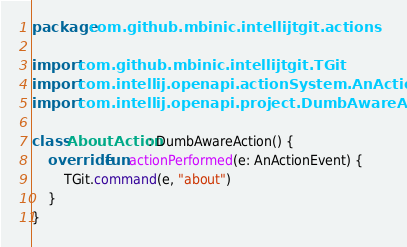Convert code to text. <code><loc_0><loc_0><loc_500><loc_500><_Kotlin_>package com.github.mbinic.intellijtgit.actions

import com.github.mbinic.intellijtgit.TGit
import com.intellij.openapi.actionSystem.AnActionEvent
import com.intellij.openapi.project.DumbAwareAction

class AboutAction : DumbAwareAction() {
    override fun actionPerformed(e: AnActionEvent) {
        TGit.command(e, "about")
    }
}
</code> 